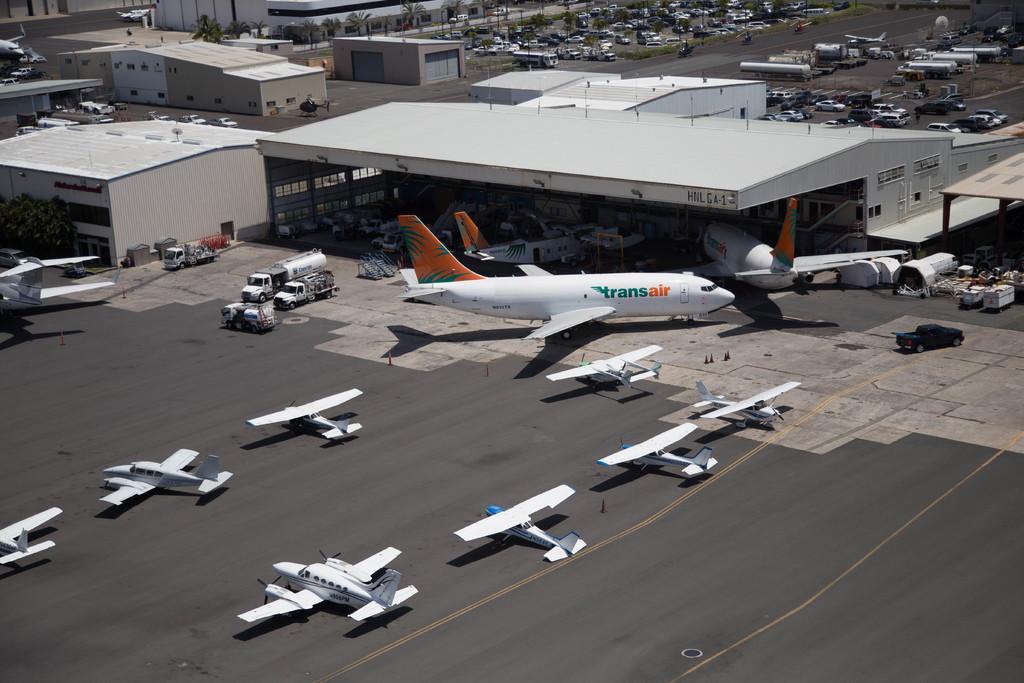In one or two sentences, can you explain what this image depicts? This is the picture of a city. In the foreground and there are aircrafts and there are vehicles. At the back there are buildings and trees and there are vehicles on the road. At the bottom there is a road. 